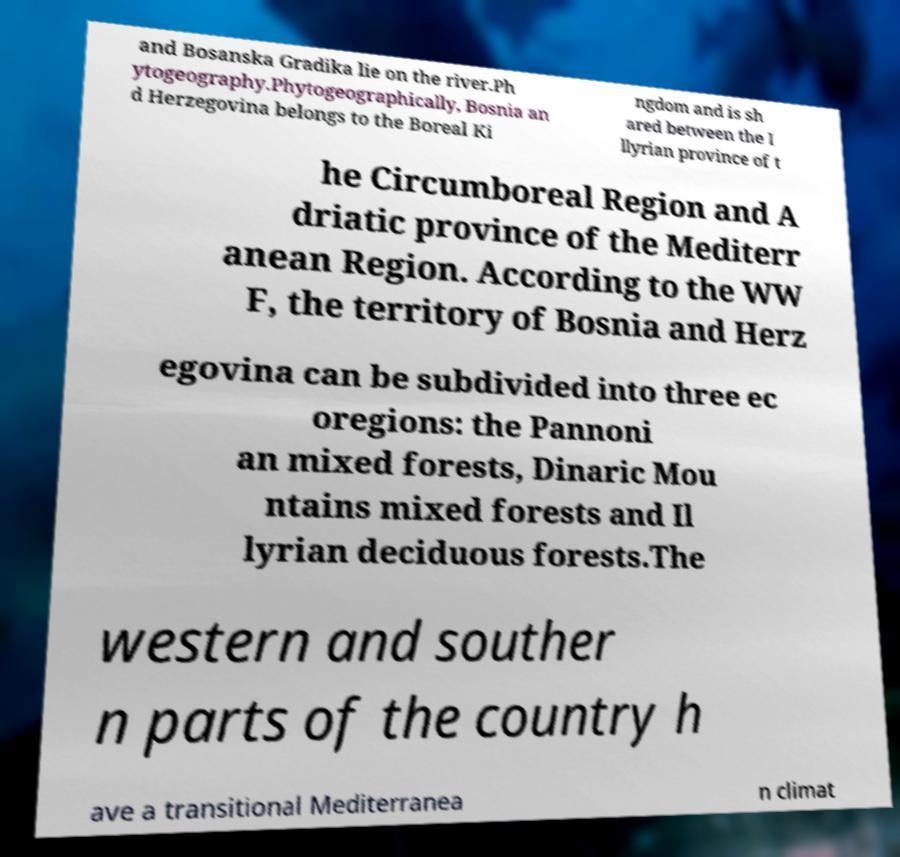I need the written content from this picture converted into text. Can you do that? and Bosanska Gradika lie on the river.Ph ytogeography.Phytogeographically, Bosnia an d Herzegovina belongs to the Boreal Ki ngdom and is sh ared between the I llyrian province of t he Circumboreal Region and A driatic province of the Mediterr anean Region. According to the WW F, the territory of Bosnia and Herz egovina can be subdivided into three ec oregions: the Pannoni an mixed forests, Dinaric Mou ntains mixed forests and Il lyrian deciduous forests.The western and souther n parts of the country h ave a transitional Mediterranea n climat 